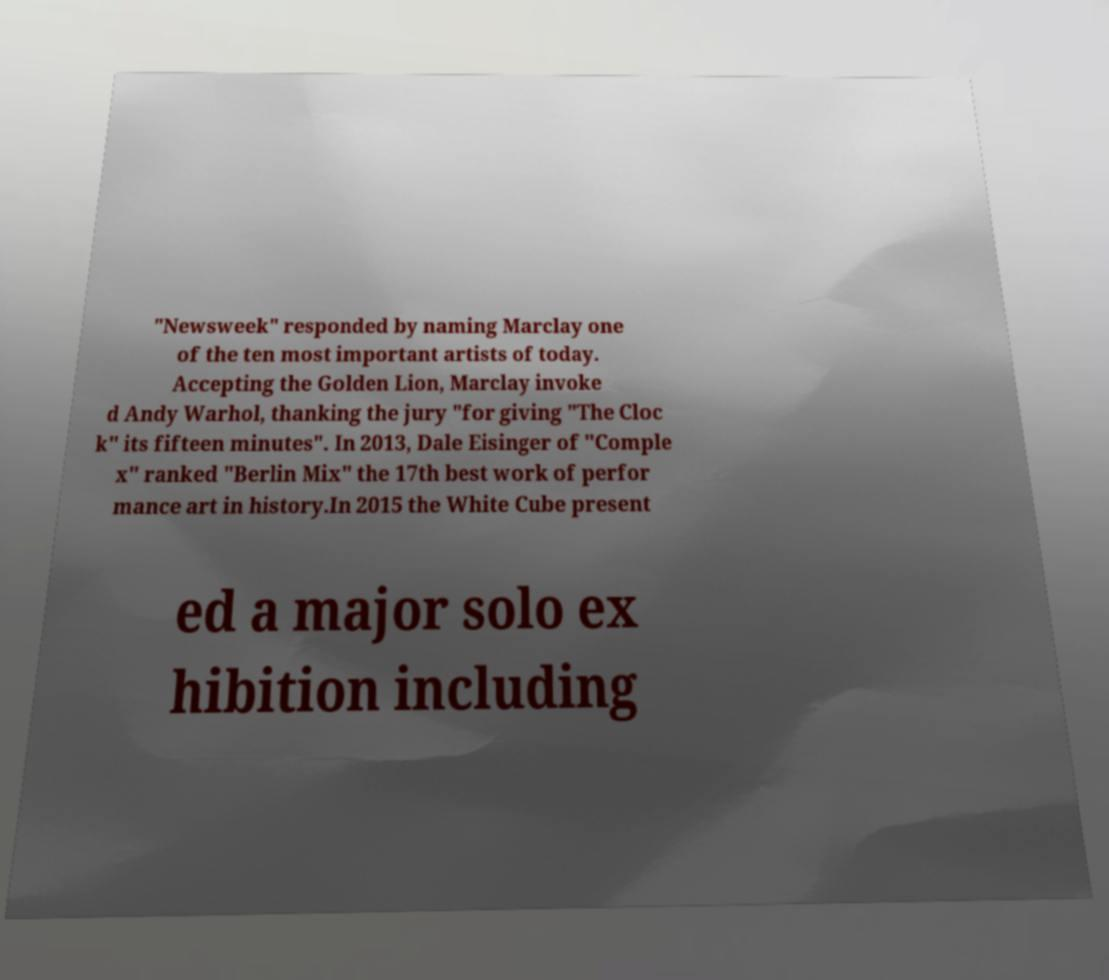There's text embedded in this image that I need extracted. Can you transcribe it verbatim? "Newsweek" responded by naming Marclay one of the ten most important artists of today. Accepting the Golden Lion, Marclay invoke d Andy Warhol, thanking the jury "for giving "The Cloc k" its fifteen minutes". In 2013, Dale Eisinger of "Comple x" ranked "Berlin Mix" the 17th best work of perfor mance art in history.In 2015 the White Cube present ed a major solo ex hibition including 